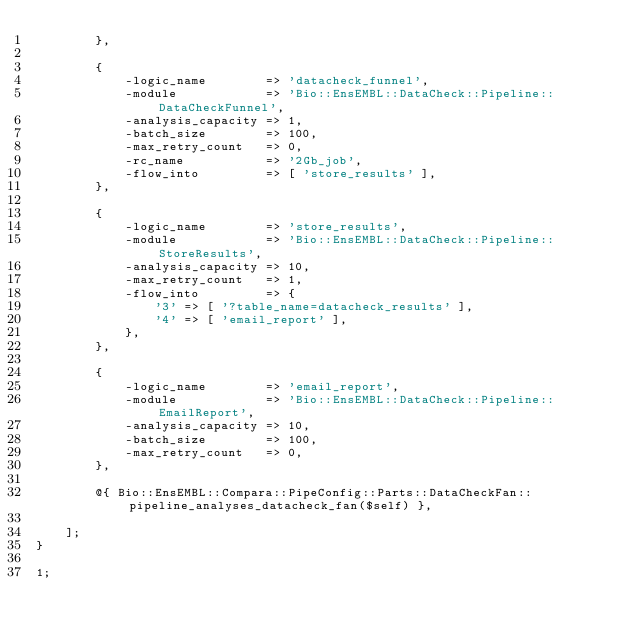Convert code to text. <code><loc_0><loc_0><loc_500><loc_500><_Perl_>        },

        {
            -logic_name        => 'datacheck_funnel',
            -module            => 'Bio::EnsEMBL::DataCheck::Pipeline::DataCheckFunnel',
            -analysis_capacity => 1,
            -batch_size        => 100,
            -max_retry_count   => 0,
            -rc_name           => '2Gb_job',
            -flow_into         => [ 'store_results' ],
        },

        {
            -logic_name        => 'store_results',
            -module            => 'Bio::EnsEMBL::DataCheck::Pipeline::StoreResults',
            -analysis_capacity => 10,
            -max_retry_count   => 1,
            -flow_into         => {
                '3' => [ '?table_name=datacheck_results' ],
                '4' => [ 'email_report' ],
            },
        },

        {
            -logic_name        => 'email_report',
            -module            => 'Bio::EnsEMBL::DataCheck::Pipeline::EmailReport',
            -analysis_capacity => 10,
            -batch_size        => 100,
            -max_retry_count   => 0,
        },

        @{ Bio::EnsEMBL::Compara::PipeConfig::Parts::DataCheckFan::pipeline_analyses_datacheck_fan($self) },

    ];
}

1;
</code> 